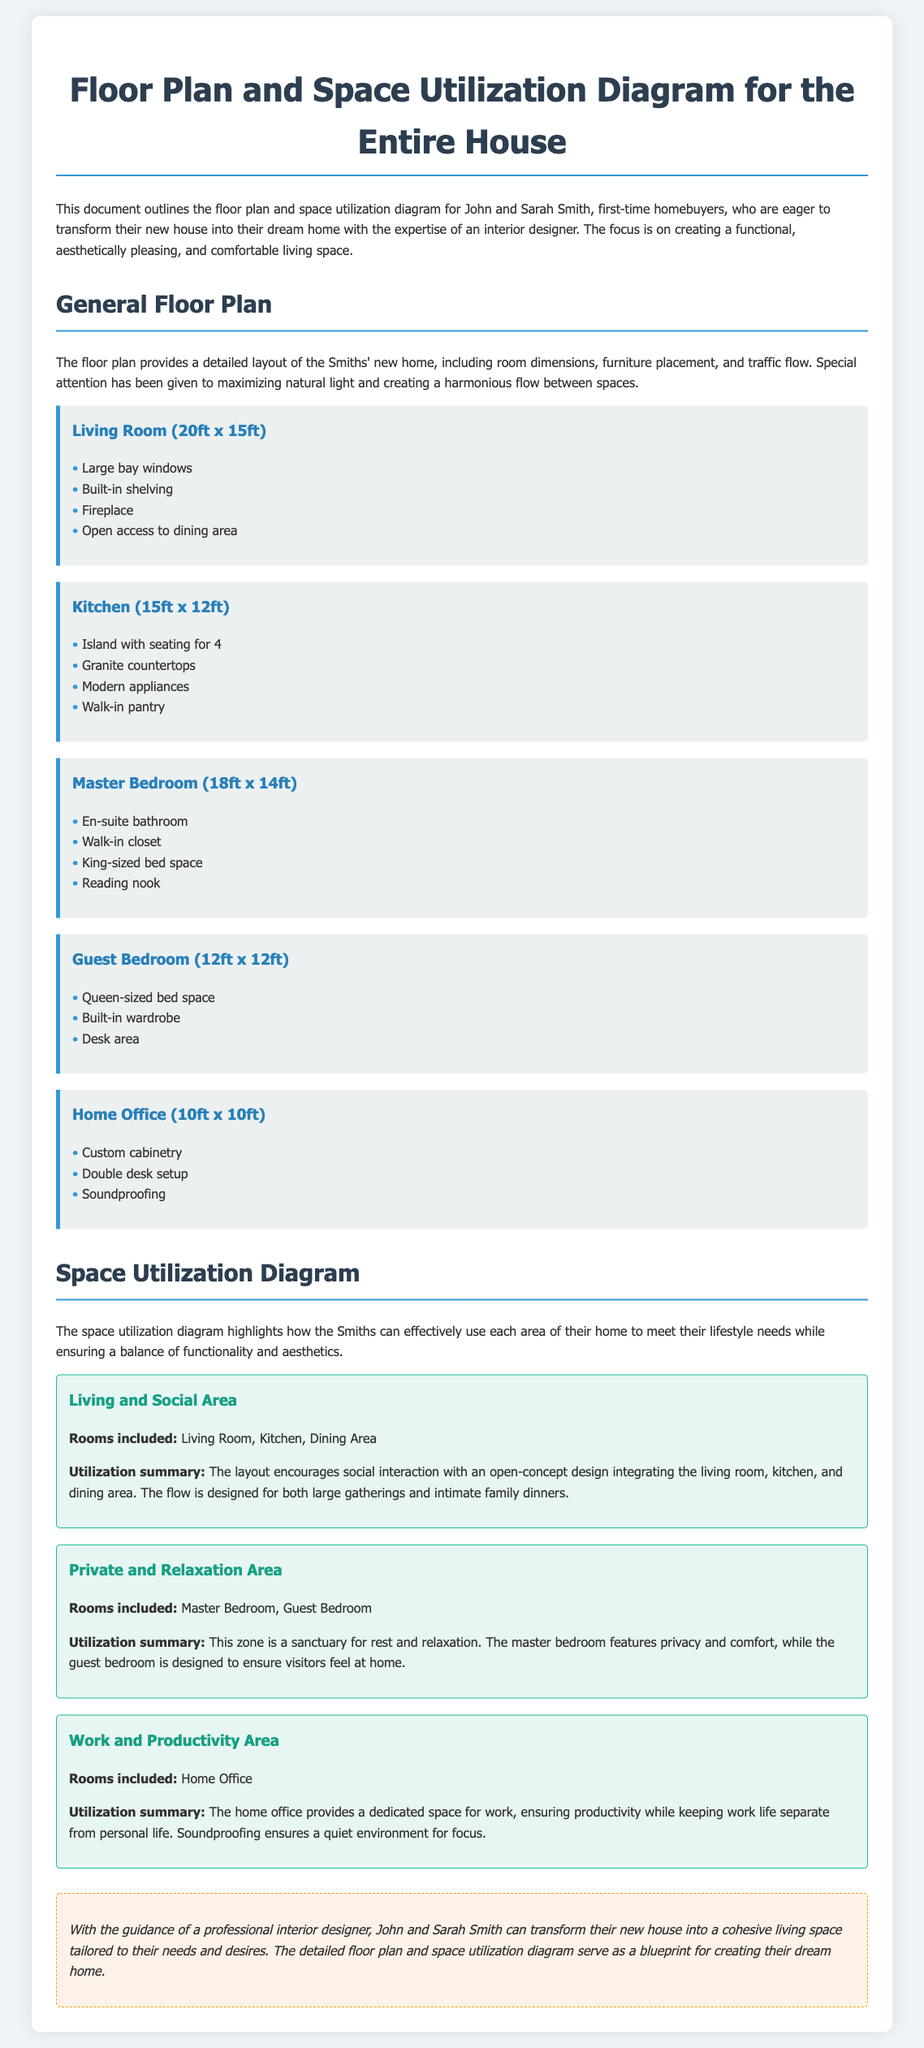What are the dimensions of the Living Room? The dimensions of the Living Room, as stated in the document, are 20ft x 15ft.
Answer: 20ft x 15ft What feature is included in the Kitchen? The document lists features included in the Kitchen, one of which is an island with seating for 4.
Answer: Island with seating for 4 Which room serves as a Work and Productivity Area? The Work and Productivity Area is specifically designated for the Home Office according to the document.
Answer: Home Office How many rooms are included in the Living and Social Area? The Living and Social Area consists of three rooms: Living Room, Kitchen, and Dining Area.
Answer: 3 What type of bed space is available in the Guest Bedroom? The bed space available in the Guest Bedroom is specified as Queen-sized in the document.
Answer: Queen-sized bed space What is the focus of the interior design for John and Sarah Smith's home? The document highlights the focus on creating a functional, aesthetically pleasing, and comfortable living space.
Answer: Functional, aesthetically pleasing, and comfortable living space What is the purpose of the Home Office according to the space utilization diagram? The Home Office is designed to provide a dedicated space for work while ensuring productivity and separation from personal life.
Answer: Dedicated space for work Which room has an en-suite bathroom? According to the document, the Master Bedroom features the en-suite bathroom.
Answer: Master Bedroom What kind of feature is emphasized in the Living Room's design? The Living Room design emphasizes large bay windows to maximize natural light.
Answer: Large bay windows 